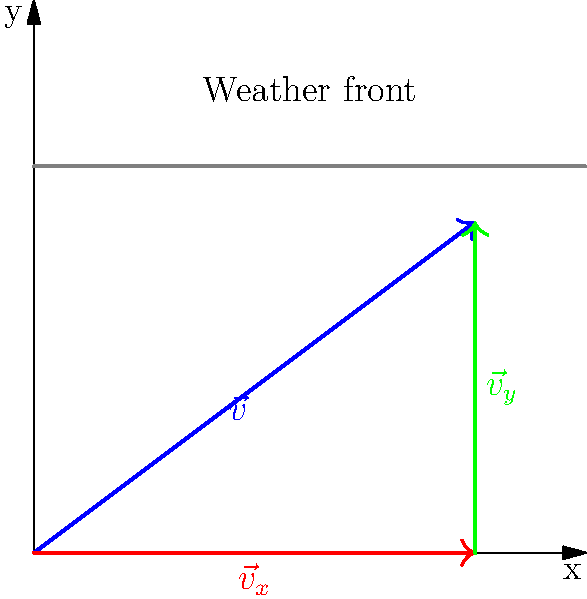As a supply coordinator, you need to optimize a route for delivering essential equipment to a forward operating base. The optimal path is represented by the blue vector $\vec{v}$ in the diagram. However, a weather front (gray line) is approaching from the north. To minimize exposure to adverse weather, you decide to break down the route into two segments: one parallel to the x-axis ($\vec{v}_x$) and one parallel to the y-axis ($\vec{v}_y$).

If the magnitude of $\vec{v}$ is 10 units and it makes an angle of 36.87° with the x-axis, what is the magnitude of $\vec{v}_x$ (the red vector)? Let's approach this step-by-step:

1) We're given that the magnitude of $\vec{v}$ is 10 units and it makes an angle of 36.87° with the x-axis.

2) $\vec{v}_x$ is the component of $\vec{v}$ along the x-axis. We can find its magnitude using the cosine function.

3) The formula for the x-component of a vector is:
   $$|\vec{v}_x| = |\vec{v}| \cos(\theta)$$
   where $|\vec{v}|$ is the magnitude of the original vector and $\theta$ is the angle it makes with the x-axis.

4) Plugging in our values:
   $$|\vec{v}_x| = 10 \cos(36.87°)$$

5) Using a calculator (or approximating):
   $$|\vec{v}_x| \approx 10 \times 0.8 = 8$$

Therefore, the magnitude of $\vec{v}_x$ is approximately 8 units.
Answer: 8 units 